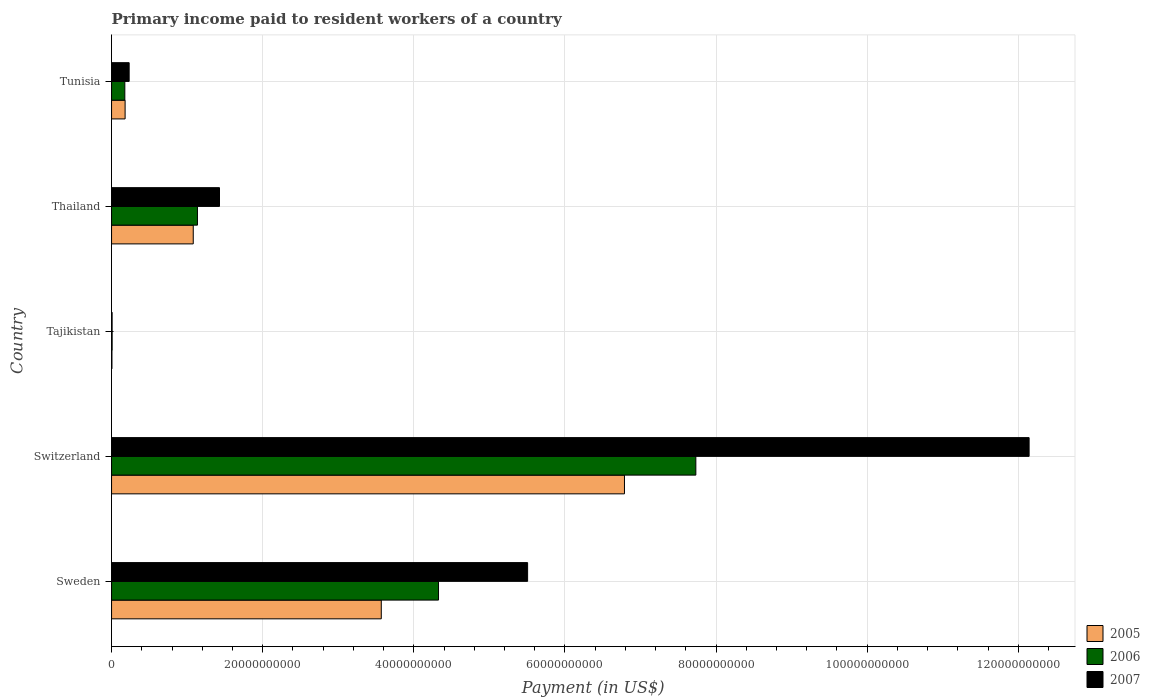How many groups of bars are there?
Offer a terse response. 5. Are the number of bars per tick equal to the number of legend labels?
Your response must be concise. Yes. Are the number of bars on each tick of the Y-axis equal?
Ensure brevity in your answer.  Yes. How many bars are there on the 3rd tick from the top?
Your response must be concise. 3. What is the label of the 2nd group of bars from the top?
Provide a short and direct response. Thailand. In how many cases, is the number of bars for a given country not equal to the number of legend labels?
Ensure brevity in your answer.  0. What is the amount paid to workers in 2007 in Tunisia?
Your answer should be compact. 2.33e+09. Across all countries, what is the maximum amount paid to workers in 2005?
Keep it short and to the point. 6.79e+1. Across all countries, what is the minimum amount paid to workers in 2005?
Give a very brief answer. 5.04e+07. In which country was the amount paid to workers in 2006 maximum?
Offer a terse response. Switzerland. In which country was the amount paid to workers in 2006 minimum?
Make the answer very short. Tajikistan. What is the total amount paid to workers in 2006 in the graph?
Provide a short and direct response. 1.34e+11. What is the difference between the amount paid to workers in 2006 in Switzerland and that in Thailand?
Keep it short and to the point. 6.60e+1. What is the difference between the amount paid to workers in 2005 in Thailand and the amount paid to workers in 2007 in Switzerland?
Offer a very short reply. -1.11e+11. What is the average amount paid to workers in 2007 per country?
Ensure brevity in your answer.  3.86e+1. What is the difference between the amount paid to workers in 2007 and amount paid to workers in 2005 in Switzerland?
Offer a terse response. 5.36e+1. In how many countries, is the amount paid to workers in 2006 greater than 20000000000 US$?
Make the answer very short. 2. What is the ratio of the amount paid to workers in 2006 in Sweden to that in Switzerland?
Your response must be concise. 0.56. Is the difference between the amount paid to workers in 2007 in Tajikistan and Thailand greater than the difference between the amount paid to workers in 2005 in Tajikistan and Thailand?
Give a very brief answer. No. What is the difference between the highest and the second highest amount paid to workers in 2006?
Give a very brief answer. 3.41e+1. What is the difference between the highest and the lowest amount paid to workers in 2007?
Your answer should be compact. 1.21e+11. In how many countries, is the amount paid to workers in 2006 greater than the average amount paid to workers in 2006 taken over all countries?
Your answer should be very brief. 2. What does the 2nd bar from the top in Thailand represents?
Keep it short and to the point. 2006. What does the 2nd bar from the bottom in Switzerland represents?
Your answer should be very brief. 2006. Is it the case that in every country, the sum of the amount paid to workers in 2006 and amount paid to workers in 2005 is greater than the amount paid to workers in 2007?
Ensure brevity in your answer.  Yes. How many bars are there?
Keep it short and to the point. 15. What is the difference between two consecutive major ticks on the X-axis?
Keep it short and to the point. 2.00e+1. Are the values on the major ticks of X-axis written in scientific E-notation?
Give a very brief answer. No. Does the graph contain any zero values?
Make the answer very short. No. Does the graph contain grids?
Your response must be concise. Yes. Where does the legend appear in the graph?
Give a very brief answer. Bottom right. How many legend labels are there?
Provide a succinct answer. 3. How are the legend labels stacked?
Your answer should be very brief. Vertical. What is the title of the graph?
Keep it short and to the point. Primary income paid to resident workers of a country. What is the label or title of the X-axis?
Your response must be concise. Payment (in US$). What is the Payment (in US$) in 2005 in Sweden?
Give a very brief answer. 3.57e+1. What is the Payment (in US$) in 2006 in Sweden?
Give a very brief answer. 4.33e+1. What is the Payment (in US$) in 2007 in Sweden?
Offer a very short reply. 5.51e+1. What is the Payment (in US$) in 2005 in Switzerland?
Your answer should be compact. 6.79e+1. What is the Payment (in US$) of 2006 in Switzerland?
Your response must be concise. 7.73e+1. What is the Payment (in US$) of 2007 in Switzerland?
Keep it short and to the point. 1.21e+11. What is the Payment (in US$) of 2005 in Tajikistan?
Provide a succinct answer. 5.04e+07. What is the Payment (in US$) in 2006 in Tajikistan?
Provide a short and direct response. 7.64e+07. What is the Payment (in US$) of 2007 in Tajikistan?
Give a very brief answer. 7.32e+07. What is the Payment (in US$) in 2005 in Thailand?
Offer a very short reply. 1.08e+1. What is the Payment (in US$) of 2006 in Thailand?
Your response must be concise. 1.14e+1. What is the Payment (in US$) in 2007 in Thailand?
Keep it short and to the point. 1.43e+1. What is the Payment (in US$) of 2005 in Tunisia?
Ensure brevity in your answer.  1.79e+09. What is the Payment (in US$) in 2006 in Tunisia?
Make the answer very short. 1.76e+09. What is the Payment (in US$) of 2007 in Tunisia?
Make the answer very short. 2.33e+09. Across all countries, what is the maximum Payment (in US$) of 2005?
Give a very brief answer. 6.79e+1. Across all countries, what is the maximum Payment (in US$) in 2006?
Your answer should be compact. 7.73e+1. Across all countries, what is the maximum Payment (in US$) in 2007?
Your answer should be compact. 1.21e+11. Across all countries, what is the minimum Payment (in US$) of 2005?
Keep it short and to the point. 5.04e+07. Across all countries, what is the minimum Payment (in US$) in 2006?
Provide a succinct answer. 7.64e+07. Across all countries, what is the minimum Payment (in US$) of 2007?
Provide a succinct answer. 7.32e+07. What is the total Payment (in US$) of 2005 in the graph?
Your response must be concise. 1.16e+11. What is the total Payment (in US$) in 2006 in the graph?
Make the answer very short. 1.34e+11. What is the total Payment (in US$) in 2007 in the graph?
Provide a succinct answer. 1.93e+11. What is the difference between the Payment (in US$) of 2005 in Sweden and that in Switzerland?
Keep it short and to the point. -3.22e+1. What is the difference between the Payment (in US$) in 2006 in Sweden and that in Switzerland?
Give a very brief answer. -3.41e+1. What is the difference between the Payment (in US$) of 2007 in Sweden and that in Switzerland?
Your answer should be compact. -6.64e+1. What is the difference between the Payment (in US$) in 2005 in Sweden and that in Tajikistan?
Make the answer very short. 3.56e+1. What is the difference between the Payment (in US$) of 2006 in Sweden and that in Tajikistan?
Your answer should be compact. 4.32e+1. What is the difference between the Payment (in US$) of 2007 in Sweden and that in Tajikistan?
Offer a terse response. 5.50e+1. What is the difference between the Payment (in US$) in 2005 in Sweden and that in Thailand?
Make the answer very short. 2.49e+1. What is the difference between the Payment (in US$) of 2006 in Sweden and that in Thailand?
Offer a terse response. 3.19e+1. What is the difference between the Payment (in US$) in 2007 in Sweden and that in Thailand?
Your answer should be very brief. 4.08e+1. What is the difference between the Payment (in US$) of 2005 in Sweden and that in Tunisia?
Provide a succinct answer. 3.39e+1. What is the difference between the Payment (in US$) of 2006 in Sweden and that in Tunisia?
Your response must be concise. 4.15e+1. What is the difference between the Payment (in US$) in 2007 in Sweden and that in Tunisia?
Ensure brevity in your answer.  5.27e+1. What is the difference between the Payment (in US$) of 2005 in Switzerland and that in Tajikistan?
Ensure brevity in your answer.  6.78e+1. What is the difference between the Payment (in US$) in 2006 in Switzerland and that in Tajikistan?
Make the answer very short. 7.73e+1. What is the difference between the Payment (in US$) in 2007 in Switzerland and that in Tajikistan?
Your answer should be compact. 1.21e+11. What is the difference between the Payment (in US$) of 2005 in Switzerland and that in Thailand?
Ensure brevity in your answer.  5.71e+1. What is the difference between the Payment (in US$) in 2006 in Switzerland and that in Thailand?
Your answer should be very brief. 6.60e+1. What is the difference between the Payment (in US$) in 2007 in Switzerland and that in Thailand?
Provide a short and direct response. 1.07e+11. What is the difference between the Payment (in US$) of 2005 in Switzerland and that in Tunisia?
Offer a terse response. 6.61e+1. What is the difference between the Payment (in US$) in 2006 in Switzerland and that in Tunisia?
Your answer should be compact. 7.56e+1. What is the difference between the Payment (in US$) of 2007 in Switzerland and that in Tunisia?
Your answer should be very brief. 1.19e+11. What is the difference between the Payment (in US$) in 2005 in Tajikistan and that in Thailand?
Your answer should be compact. -1.08e+1. What is the difference between the Payment (in US$) of 2006 in Tajikistan and that in Thailand?
Provide a short and direct response. -1.13e+1. What is the difference between the Payment (in US$) in 2007 in Tajikistan and that in Thailand?
Your answer should be very brief. -1.42e+1. What is the difference between the Payment (in US$) in 2005 in Tajikistan and that in Tunisia?
Give a very brief answer. -1.74e+09. What is the difference between the Payment (in US$) of 2006 in Tajikistan and that in Tunisia?
Your answer should be very brief. -1.68e+09. What is the difference between the Payment (in US$) of 2007 in Tajikistan and that in Tunisia?
Your answer should be very brief. -2.26e+09. What is the difference between the Payment (in US$) of 2005 in Thailand and that in Tunisia?
Give a very brief answer. 9.02e+09. What is the difference between the Payment (in US$) of 2006 in Thailand and that in Tunisia?
Keep it short and to the point. 9.61e+09. What is the difference between the Payment (in US$) in 2007 in Thailand and that in Tunisia?
Provide a succinct answer. 1.20e+1. What is the difference between the Payment (in US$) in 2005 in Sweden and the Payment (in US$) in 2006 in Switzerland?
Ensure brevity in your answer.  -4.16e+1. What is the difference between the Payment (in US$) of 2005 in Sweden and the Payment (in US$) of 2007 in Switzerland?
Keep it short and to the point. -8.57e+1. What is the difference between the Payment (in US$) in 2006 in Sweden and the Payment (in US$) in 2007 in Switzerland?
Keep it short and to the point. -7.82e+1. What is the difference between the Payment (in US$) in 2005 in Sweden and the Payment (in US$) in 2006 in Tajikistan?
Your answer should be compact. 3.56e+1. What is the difference between the Payment (in US$) of 2005 in Sweden and the Payment (in US$) of 2007 in Tajikistan?
Ensure brevity in your answer.  3.56e+1. What is the difference between the Payment (in US$) of 2006 in Sweden and the Payment (in US$) of 2007 in Tajikistan?
Ensure brevity in your answer.  4.32e+1. What is the difference between the Payment (in US$) of 2005 in Sweden and the Payment (in US$) of 2006 in Thailand?
Keep it short and to the point. 2.43e+1. What is the difference between the Payment (in US$) in 2005 in Sweden and the Payment (in US$) in 2007 in Thailand?
Provide a short and direct response. 2.14e+1. What is the difference between the Payment (in US$) in 2006 in Sweden and the Payment (in US$) in 2007 in Thailand?
Your answer should be compact. 2.90e+1. What is the difference between the Payment (in US$) of 2005 in Sweden and the Payment (in US$) of 2006 in Tunisia?
Provide a succinct answer. 3.39e+1. What is the difference between the Payment (in US$) of 2005 in Sweden and the Payment (in US$) of 2007 in Tunisia?
Provide a succinct answer. 3.34e+1. What is the difference between the Payment (in US$) in 2006 in Sweden and the Payment (in US$) in 2007 in Tunisia?
Ensure brevity in your answer.  4.09e+1. What is the difference between the Payment (in US$) in 2005 in Switzerland and the Payment (in US$) in 2006 in Tajikistan?
Make the answer very short. 6.78e+1. What is the difference between the Payment (in US$) of 2005 in Switzerland and the Payment (in US$) of 2007 in Tajikistan?
Your answer should be very brief. 6.78e+1. What is the difference between the Payment (in US$) in 2006 in Switzerland and the Payment (in US$) in 2007 in Tajikistan?
Your answer should be compact. 7.73e+1. What is the difference between the Payment (in US$) in 2005 in Switzerland and the Payment (in US$) in 2006 in Thailand?
Your response must be concise. 5.65e+1. What is the difference between the Payment (in US$) of 2005 in Switzerland and the Payment (in US$) of 2007 in Thailand?
Give a very brief answer. 5.36e+1. What is the difference between the Payment (in US$) in 2006 in Switzerland and the Payment (in US$) in 2007 in Thailand?
Ensure brevity in your answer.  6.30e+1. What is the difference between the Payment (in US$) of 2005 in Switzerland and the Payment (in US$) of 2006 in Tunisia?
Ensure brevity in your answer.  6.61e+1. What is the difference between the Payment (in US$) of 2005 in Switzerland and the Payment (in US$) of 2007 in Tunisia?
Offer a terse response. 6.56e+1. What is the difference between the Payment (in US$) in 2006 in Switzerland and the Payment (in US$) in 2007 in Tunisia?
Ensure brevity in your answer.  7.50e+1. What is the difference between the Payment (in US$) of 2005 in Tajikistan and the Payment (in US$) of 2006 in Thailand?
Provide a short and direct response. -1.13e+1. What is the difference between the Payment (in US$) of 2005 in Tajikistan and the Payment (in US$) of 2007 in Thailand?
Offer a very short reply. -1.42e+1. What is the difference between the Payment (in US$) of 2006 in Tajikistan and the Payment (in US$) of 2007 in Thailand?
Offer a very short reply. -1.42e+1. What is the difference between the Payment (in US$) of 2005 in Tajikistan and the Payment (in US$) of 2006 in Tunisia?
Offer a terse response. -1.71e+09. What is the difference between the Payment (in US$) in 2005 in Tajikistan and the Payment (in US$) in 2007 in Tunisia?
Make the answer very short. -2.28e+09. What is the difference between the Payment (in US$) in 2006 in Tajikistan and the Payment (in US$) in 2007 in Tunisia?
Your answer should be compact. -2.25e+09. What is the difference between the Payment (in US$) in 2005 in Thailand and the Payment (in US$) in 2006 in Tunisia?
Provide a short and direct response. 9.06e+09. What is the difference between the Payment (in US$) in 2005 in Thailand and the Payment (in US$) in 2007 in Tunisia?
Provide a short and direct response. 8.48e+09. What is the difference between the Payment (in US$) of 2006 in Thailand and the Payment (in US$) of 2007 in Tunisia?
Your response must be concise. 9.04e+09. What is the average Payment (in US$) of 2005 per country?
Your answer should be compact. 2.32e+1. What is the average Payment (in US$) of 2006 per country?
Provide a succinct answer. 2.68e+1. What is the average Payment (in US$) of 2007 per country?
Make the answer very short. 3.86e+1. What is the difference between the Payment (in US$) of 2005 and Payment (in US$) of 2006 in Sweden?
Offer a very short reply. -7.57e+09. What is the difference between the Payment (in US$) in 2005 and Payment (in US$) in 2007 in Sweden?
Keep it short and to the point. -1.94e+1. What is the difference between the Payment (in US$) of 2006 and Payment (in US$) of 2007 in Sweden?
Make the answer very short. -1.18e+1. What is the difference between the Payment (in US$) of 2005 and Payment (in US$) of 2006 in Switzerland?
Provide a succinct answer. -9.45e+09. What is the difference between the Payment (in US$) of 2005 and Payment (in US$) of 2007 in Switzerland?
Provide a short and direct response. -5.36e+1. What is the difference between the Payment (in US$) of 2006 and Payment (in US$) of 2007 in Switzerland?
Your answer should be very brief. -4.41e+1. What is the difference between the Payment (in US$) of 2005 and Payment (in US$) of 2006 in Tajikistan?
Your answer should be very brief. -2.60e+07. What is the difference between the Payment (in US$) of 2005 and Payment (in US$) of 2007 in Tajikistan?
Your response must be concise. -2.28e+07. What is the difference between the Payment (in US$) of 2006 and Payment (in US$) of 2007 in Tajikistan?
Offer a terse response. 3.18e+06. What is the difference between the Payment (in US$) in 2005 and Payment (in US$) in 2006 in Thailand?
Ensure brevity in your answer.  -5.56e+08. What is the difference between the Payment (in US$) of 2005 and Payment (in US$) of 2007 in Thailand?
Give a very brief answer. -3.47e+09. What is the difference between the Payment (in US$) of 2006 and Payment (in US$) of 2007 in Thailand?
Give a very brief answer. -2.92e+09. What is the difference between the Payment (in US$) in 2005 and Payment (in US$) in 2006 in Tunisia?
Your answer should be very brief. 3.87e+07. What is the difference between the Payment (in US$) of 2005 and Payment (in US$) of 2007 in Tunisia?
Give a very brief answer. -5.35e+08. What is the difference between the Payment (in US$) in 2006 and Payment (in US$) in 2007 in Tunisia?
Provide a short and direct response. -5.73e+08. What is the ratio of the Payment (in US$) of 2005 in Sweden to that in Switzerland?
Keep it short and to the point. 0.53. What is the ratio of the Payment (in US$) of 2006 in Sweden to that in Switzerland?
Your response must be concise. 0.56. What is the ratio of the Payment (in US$) of 2007 in Sweden to that in Switzerland?
Make the answer very short. 0.45. What is the ratio of the Payment (in US$) of 2005 in Sweden to that in Tajikistan?
Keep it short and to the point. 708.84. What is the ratio of the Payment (in US$) of 2006 in Sweden to that in Tajikistan?
Make the answer very short. 566.77. What is the ratio of the Payment (in US$) of 2007 in Sweden to that in Tajikistan?
Your response must be concise. 752.6. What is the ratio of the Payment (in US$) of 2005 in Sweden to that in Thailand?
Offer a very short reply. 3.3. What is the ratio of the Payment (in US$) in 2006 in Sweden to that in Thailand?
Offer a very short reply. 3.81. What is the ratio of the Payment (in US$) of 2007 in Sweden to that in Thailand?
Offer a terse response. 3.85. What is the ratio of the Payment (in US$) of 2005 in Sweden to that in Tunisia?
Make the answer very short. 19.89. What is the ratio of the Payment (in US$) in 2006 in Sweden to that in Tunisia?
Your answer should be very brief. 24.65. What is the ratio of the Payment (in US$) in 2007 in Sweden to that in Tunisia?
Make the answer very short. 23.64. What is the ratio of the Payment (in US$) in 2005 in Switzerland to that in Tajikistan?
Ensure brevity in your answer.  1347.9. What is the ratio of the Payment (in US$) of 2006 in Switzerland to that in Tajikistan?
Offer a very short reply. 1012.85. What is the ratio of the Payment (in US$) of 2007 in Switzerland to that in Tajikistan?
Ensure brevity in your answer.  1659.76. What is the ratio of the Payment (in US$) of 2005 in Switzerland to that in Thailand?
Give a very brief answer. 6.28. What is the ratio of the Payment (in US$) of 2006 in Switzerland to that in Thailand?
Your answer should be compact. 6.8. What is the ratio of the Payment (in US$) of 2007 in Switzerland to that in Thailand?
Your answer should be very brief. 8.5. What is the ratio of the Payment (in US$) in 2005 in Switzerland to that in Tunisia?
Keep it short and to the point. 37.83. What is the ratio of the Payment (in US$) of 2006 in Switzerland to that in Tunisia?
Keep it short and to the point. 44.04. What is the ratio of the Payment (in US$) of 2007 in Switzerland to that in Tunisia?
Offer a very short reply. 52.14. What is the ratio of the Payment (in US$) of 2005 in Tajikistan to that in Thailand?
Ensure brevity in your answer.  0. What is the ratio of the Payment (in US$) in 2006 in Tajikistan to that in Thailand?
Offer a terse response. 0.01. What is the ratio of the Payment (in US$) of 2007 in Tajikistan to that in Thailand?
Offer a very short reply. 0.01. What is the ratio of the Payment (in US$) in 2005 in Tajikistan to that in Tunisia?
Your response must be concise. 0.03. What is the ratio of the Payment (in US$) of 2006 in Tajikistan to that in Tunisia?
Keep it short and to the point. 0.04. What is the ratio of the Payment (in US$) in 2007 in Tajikistan to that in Tunisia?
Offer a very short reply. 0.03. What is the ratio of the Payment (in US$) in 2005 in Thailand to that in Tunisia?
Ensure brevity in your answer.  6.02. What is the ratio of the Payment (in US$) in 2006 in Thailand to that in Tunisia?
Keep it short and to the point. 6.47. What is the ratio of the Payment (in US$) in 2007 in Thailand to that in Tunisia?
Provide a succinct answer. 6.13. What is the difference between the highest and the second highest Payment (in US$) in 2005?
Provide a succinct answer. 3.22e+1. What is the difference between the highest and the second highest Payment (in US$) in 2006?
Give a very brief answer. 3.41e+1. What is the difference between the highest and the second highest Payment (in US$) in 2007?
Ensure brevity in your answer.  6.64e+1. What is the difference between the highest and the lowest Payment (in US$) of 2005?
Provide a short and direct response. 6.78e+1. What is the difference between the highest and the lowest Payment (in US$) of 2006?
Give a very brief answer. 7.73e+1. What is the difference between the highest and the lowest Payment (in US$) of 2007?
Your response must be concise. 1.21e+11. 